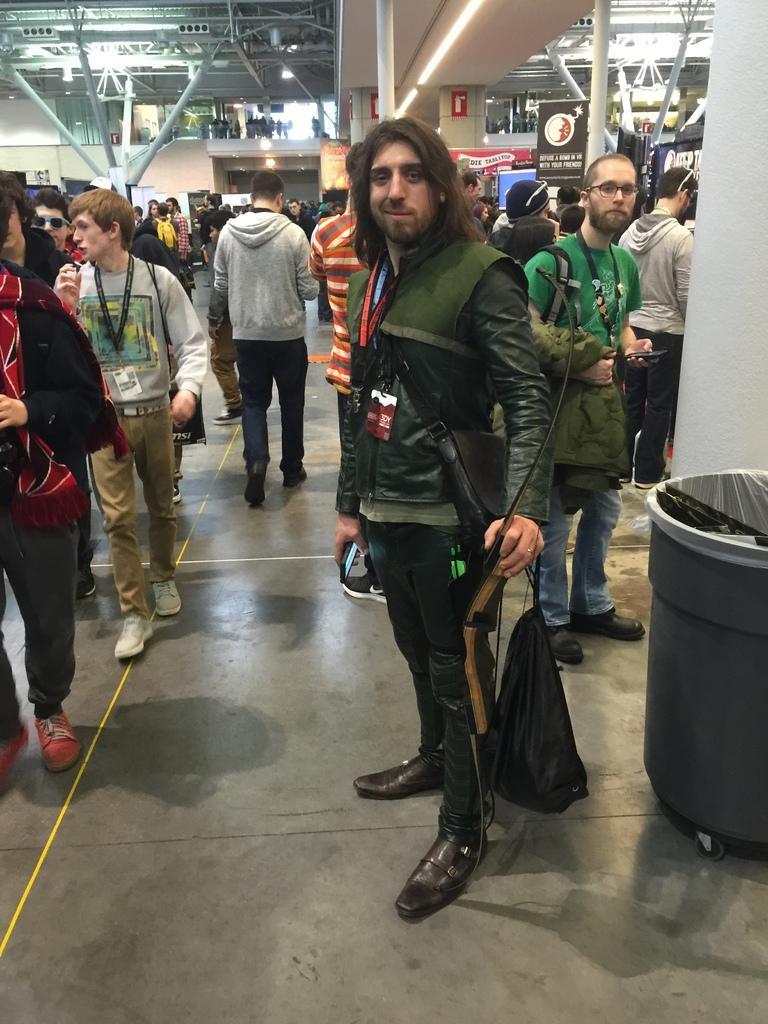Could you give a brief overview of what you see in this image? In this image I can see a person wearing green, black and blue colored dress is standing and holding a black colored bag. I can see a bin which is black in color and number of persons standing. In the background I can see the building, few lights, few boards, the ceiling, few metal rods and few persons standing. 